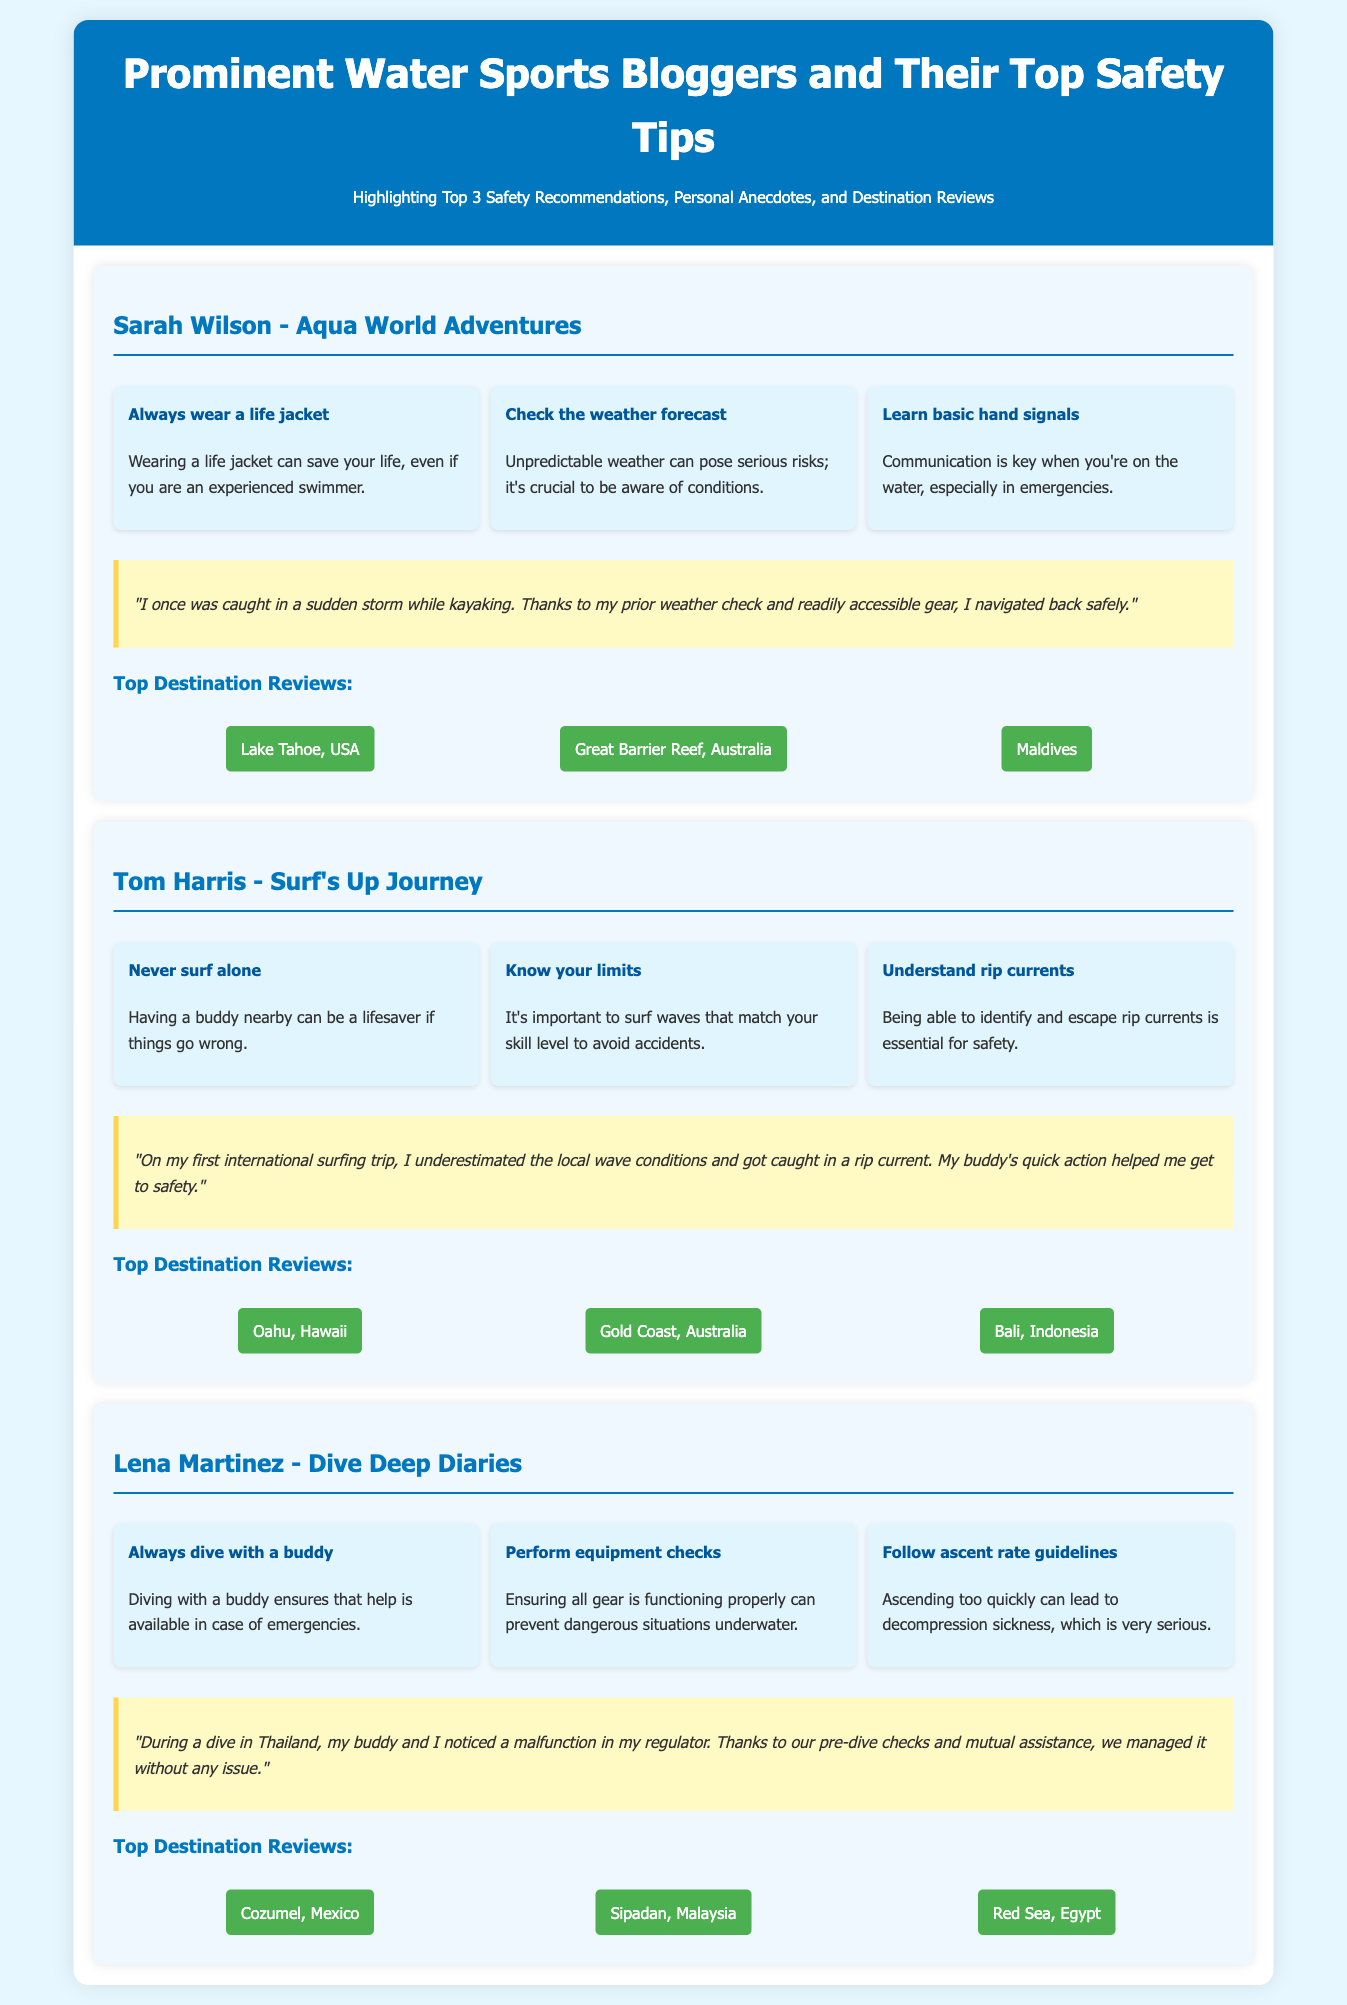What is Sarah Wilson's blog name? The blog name associated with Sarah Wilson is Aqua World Adventures.
Answer: Aqua World Adventures What is one of Tom Harris's top safety tips? The document lists three safety tips for Tom Harris, one of which is "Never surf alone."
Answer: Never surf alone How many bloggers are featured in the document? The document highlights a total of three prominent water sports bloggers.
Answer: Three What personal anecdote does Lena Martinez share? Lena Martinez shares an anecdote about noticing a malfunction in her regulator during a dive in Thailand.
Answer: Noticing a malfunction in my regulator during a dive in Thailand What is one recommended destination from Dive Deep Diaries? The document includes a list of recommended destinations, such as Cozumel, Mexico.
Answer: Cozumel, Mexico What is the safety recommendation regarding life jackets? The recommendation states that wearing a life jacket can save your life, even if you are an experienced swimmer.
Answer: Always wear a life jacket How many safety recommendations does each blogger provide? Each blogger provides three top safety recommendations.
Answer: Three What is a common theme in the safety tips provided by the bloggers? A common theme in their safety tips is the emphasis on having a buddy or partner while engaging in water sports.
Answer: Buddy system 